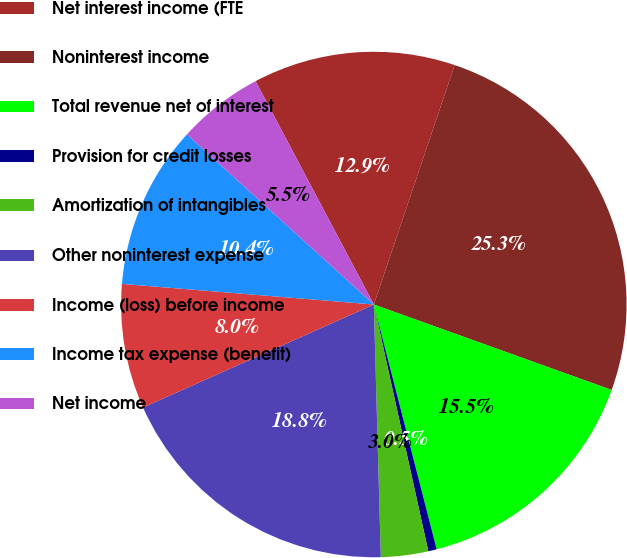Convert chart. <chart><loc_0><loc_0><loc_500><loc_500><pie_chart><fcel>Net interest income (FTE<fcel>Noninterest income<fcel>Total revenue net of interest<fcel>Provision for credit losses<fcel>Amortization of intangibles<fcel>Other noninterest expense<fcel>Income (loss) before income<fcel>Income tax expense (benefit)<fcel>Net income<nl><fcel>12.93%<fcel>25.31%<fcel>15.51%<fcel>0.54%<fcel>3.02%<fcel>18.76%<fcel>7.98%<fcel>10.45%<fcel>5.5%<nl></chart> 